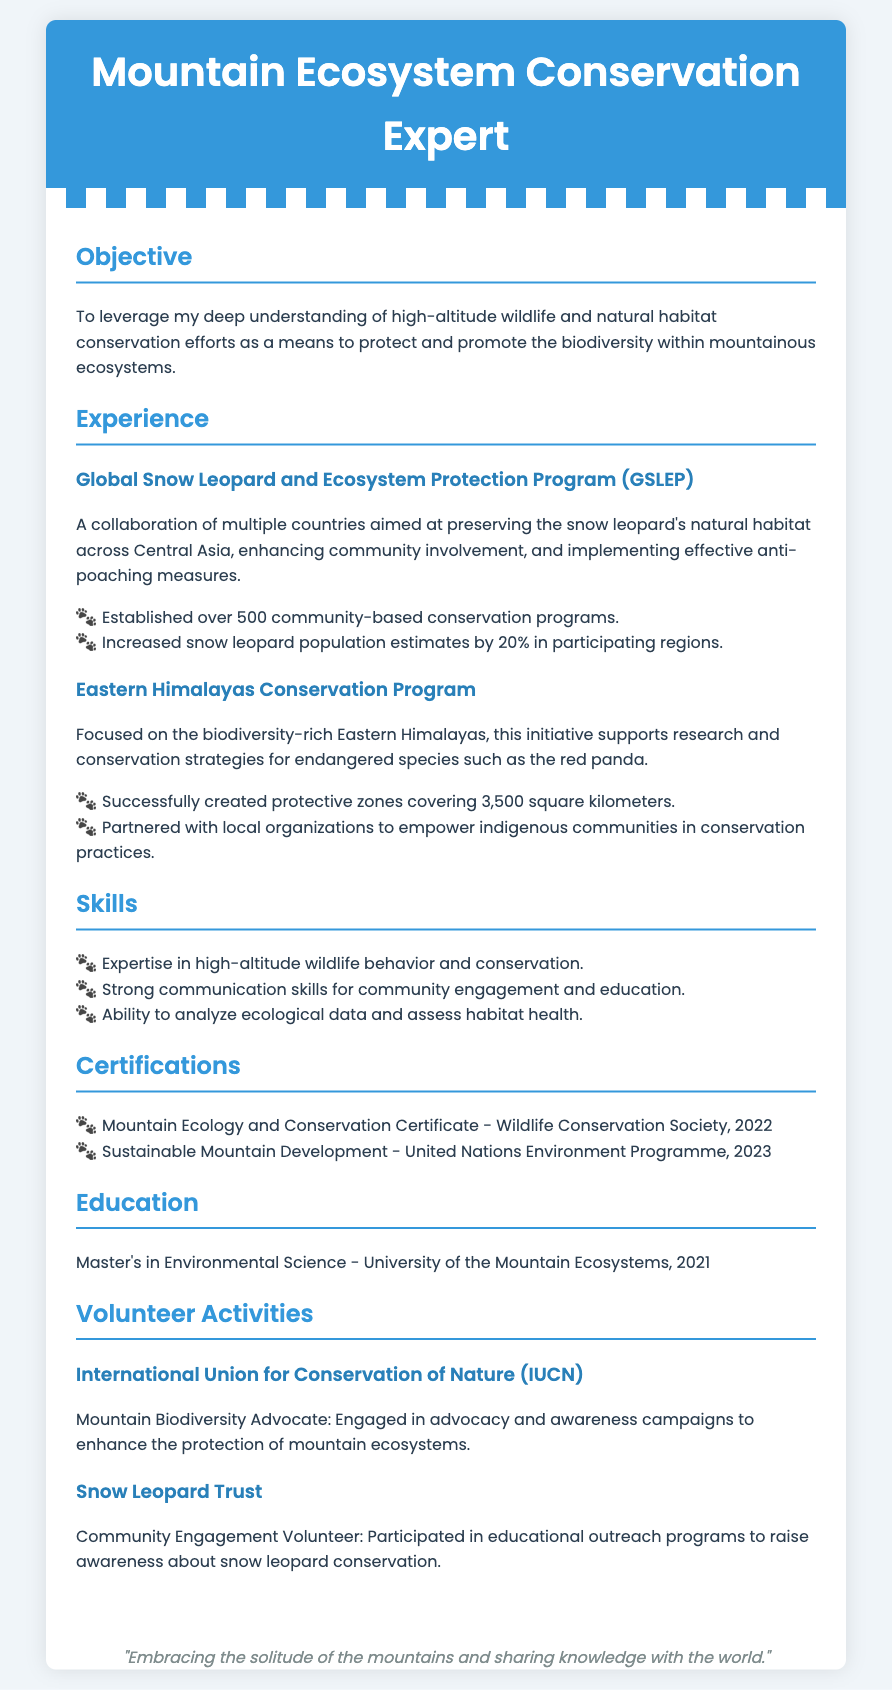What is the objective of the resume? The objective summarizes the aim of the individual to protect and promote biodiversity in mountainous ecosystems.
Answer: To leverage my deep understanding of high-altitude wildlife and natural habitat conservation efforts as a means to protect and promote the biodiversity within mountainous ecosystems How many community-based conservation programs were established? This information is found under the GSLEP experience section, highlighting the number of programs initiated.
Answer: Over 500 What is one endangered species mentioned in the document? This specific detail can be found in the Eastern Himalayas Conservation Program section, which lists species that are studied and protected.
Answer: Red panda What is the area covered by protective zones created under the Eastern Himalayas Conservation Program? This figure represents the total area of protective zones established for conservation in the region.
Answer: 3,500 square kilometers What certification was obtained in 2022? This asks for a specific certification gained by the individual, as listed under the certifications section.
Answer: Mountain Ecology and Conservation Certificate Which organization did the individual volunteer for that focuses on snow leopards? This detail mentions a specific organization where the individual has been involved in outreach and community engagement related to snow leopards.
Answer: Snow Leopard Trust What is the highest level of education attained by the individual? This question refers to the educational background provided in the resume, focusing on the degree achieved.
Answer: Master's in Environmental Science What skills are highlighted in the resume? This asks for a brief list of the primary skills mentioned, showcasing expertise relevant to conservation.
Answer: Expertise in high-altitude wildlife behavior and conservation, Strong communication skills for community engagement and education, Ability to analyze ecological data and assess habitat health Which program focuses on the preservation of the snow leopard's habitat? This pertains to the specific collaboration mentioned in the experience section dedicated to the conservation of a particular species.
Answer: Global Snow Leopard and Ecosystem Protection Program 